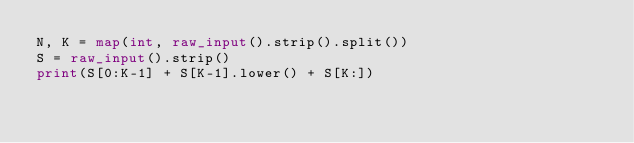<code> <loc_0><loc_0><loc_500><loc_500><_Python_>N, K = map(int, raw_input().strip().split())
S = raw_input().strip()
print(S[0:K-1] + S[K-1].lower() + S[K:])</code> 